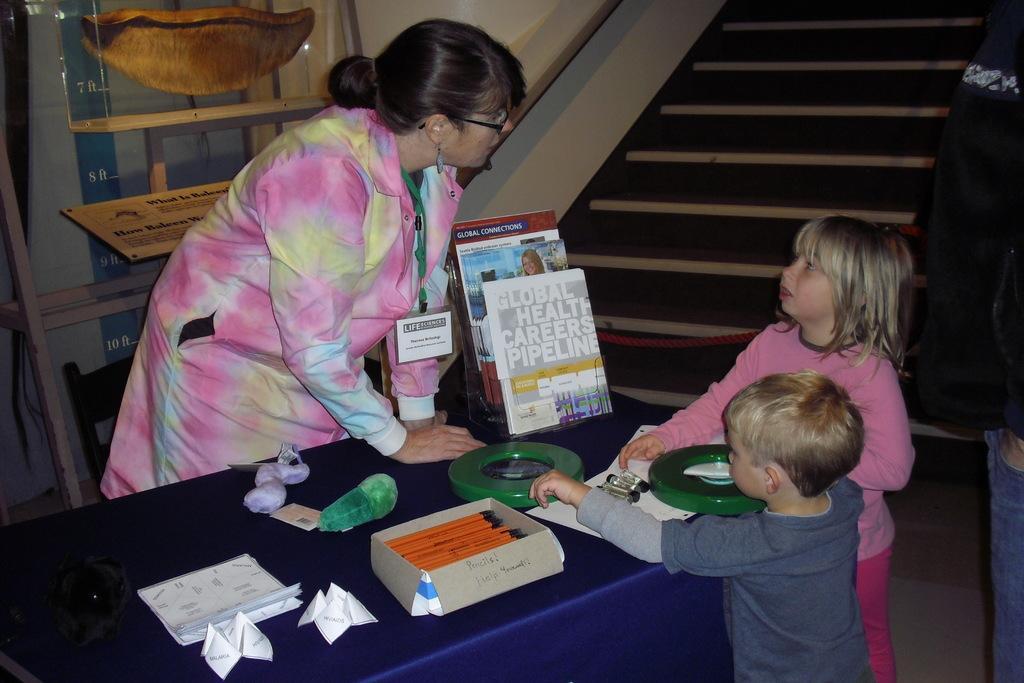Describe this image in one or two sentences. In this image there are people. At the bottom there is a table and we can see a box, books, papers, toys and some objects placed on the table. In the background there are stairs and we can see a board. 